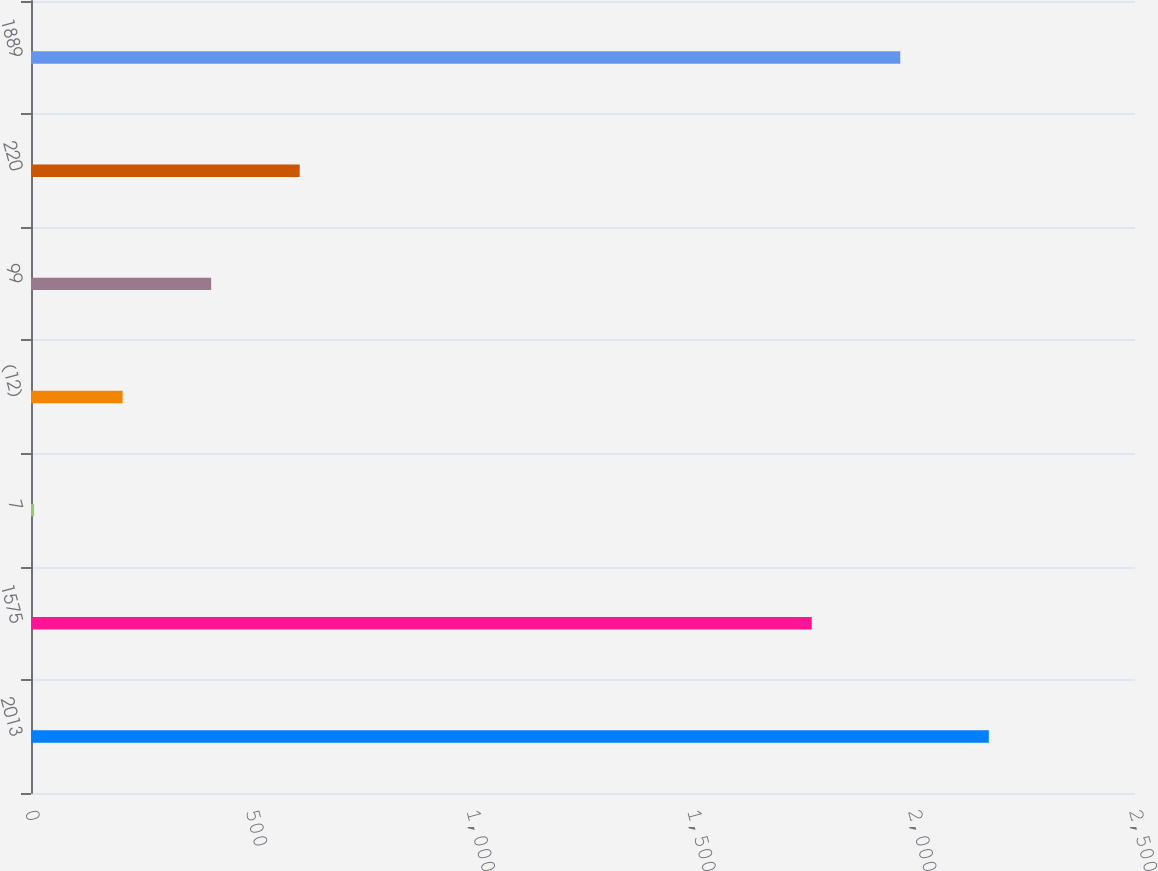<chart> <loc_0><loc_0><loc_500><loc_500><bar_chart><fcel>2013<fcel>1575<fcel>7<fcel>(12)<fcel>99<fcel>220<fcel>1889<nl><fcel>2169<fcel>1768<fcel>7<fcel>207.5<fcel>408<fcel>608.5<fcel>1968.5<nl></chart> 